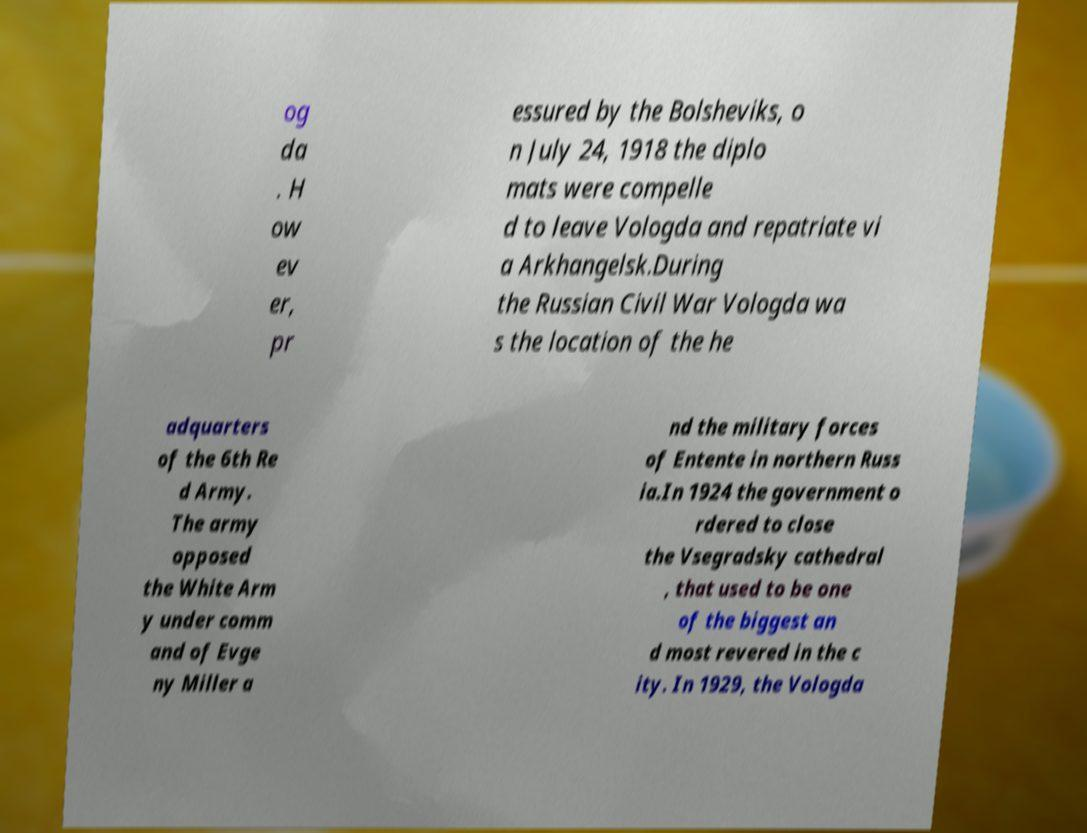I need the written content from this picture converted into text. Can you do that? og da . H ow ev er, pr essured by the Bolsheviks, o n July 24, 1918 the diplo mats were compelle d to leave Vologda and repatriate vi a Arkhangelsk.During the Russian Civil War Vologda wa s the location of the he adquarters of the 6th Re d Army. The army opposed the White Arm y under comm and of Evge ny Miller a nd the military forces of Entente in northern Russ ia.In 1924 the government o rdered to close the Vsegradsky cathedral , that used to be one of the biggest an d most revered in the c ity. In 1929, the Vologda 